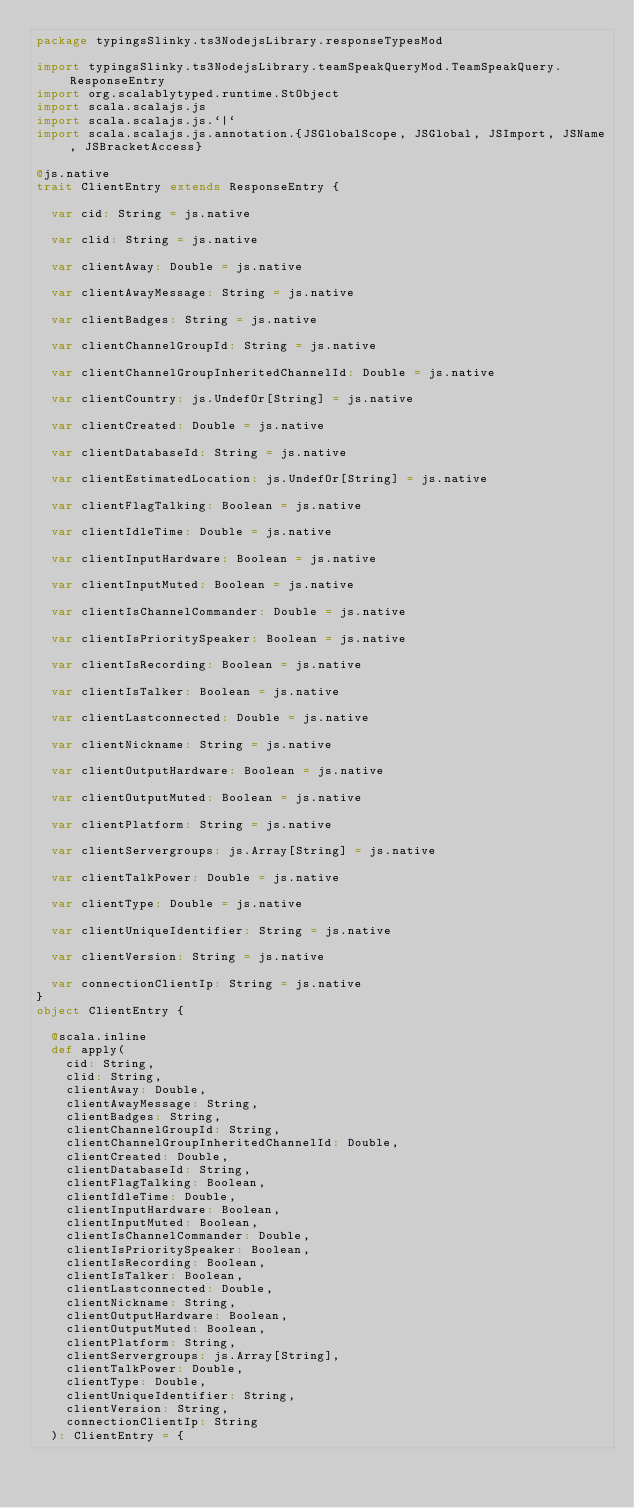<code> <loc_0><loc_0><loc_500><loc_500><_Scala_>package typingsSlinky.ts3NodejsLibrary.responseTypesMod

import typingsSlinky.ts3NodejsLibrary.teamSpeakQueryMod.TeamSpeakQuery.ResponseEntry
import org.scalablytyped.runtime.StObject
import scala.scalajs.js
import scala.scalajs.js.`|`
import scala.scalajs.js.annotation.{JSGlobalScope, JSGlobal, JSImport, JSName, JSBracketAccess}

@js.native
trait ClientEntry extends ResponseEntry {
  
  var cid: String = js.native
  
  var clid: String = js.native
  
  var clientAway: Double = js.native
  
  var clientAwayMessage: String = js.native
  
  var clientBadges: String = js.native
  
  var clientChannelGroupId: String = js.native
  
  var clientChannelGroupInheritedChannelId: Double = js.native
  
  var clientCountry: js.UndefOr[String] = js.native
  
  var clientCreated: Double = js.native
  
  var clientDatabaseId: String = js.native
  
  var clientEstimatedLocation: js.UndefOr[String] = js.native
  
  var clientFlagTalking: Boolean = js.native
  
  var clientIdleTime: Double = js.native
  
  var clientInputHardware: Boolean = js.native
  
  var clientInputMuted: Boolean = js.native
  
  var clientIsChannelCommander: Double = js.native
  
  var clientIsPrioritySpeaker: Boolean = js.native
  
  var clientIsRecording: Boolean = js.native
  
  var clientIsTalker: Boolean = js.native
  
  var clientLastconnected: Double = js.native
  
  var clientNickname: String = js.native
  
  var clientOutputHardware: Boolean = js.native
  
  var clientOutputMuted: Boolean = js.native
  
  var clientPlatform: String = js.native
  
  var clientServergroups: js.Array[String] = js.native
  
  var clientTalkPower: Double = js.native
  
  var clientType: Double = js.native
  
  var clientUniqueIdentifier: String = js.native
  
  var clientVersion: String = js.native
  
  var connectionClientIp: String = js.native
}
object ClientEntry {
  
  @scala.inline
  def apply(
    cid: String,
    clid: String,
    clientAway: Double,
    clientAwayMessage: String,
    clientBadges: String,
    clientChannelGroupId: String,
    clientChannelGroupInheritedChannelId: Double,
    clientCreated: Double,
    clientDatabaseId: String,
    clientFlagTalking: Boolean,
    clientIdleTime: Double,
    clientInputHardware: Boolean,
    clientInputMuted: Boolean,
    clientIsChannelCommander: Double,
    clientIsPrioritySpeaker: Boolean,
    clientIsRecording: Boolean,
    clientIsTalker: Boolean,
    clientLastconnected: Double,
    clientNickname: String,
    clientOutputHardware: Boolean,
    clientOutputMuted: Boolean,
    clientPlatform: String,
    clientServergroups: js.Array[String],
    clientTalkPower: Double,
    clientType: Double,
    clientUniqueIdentifier: String,
    clientVersion: String,
    connectionClientIp: String
  ): ClientEntry = {</code> 